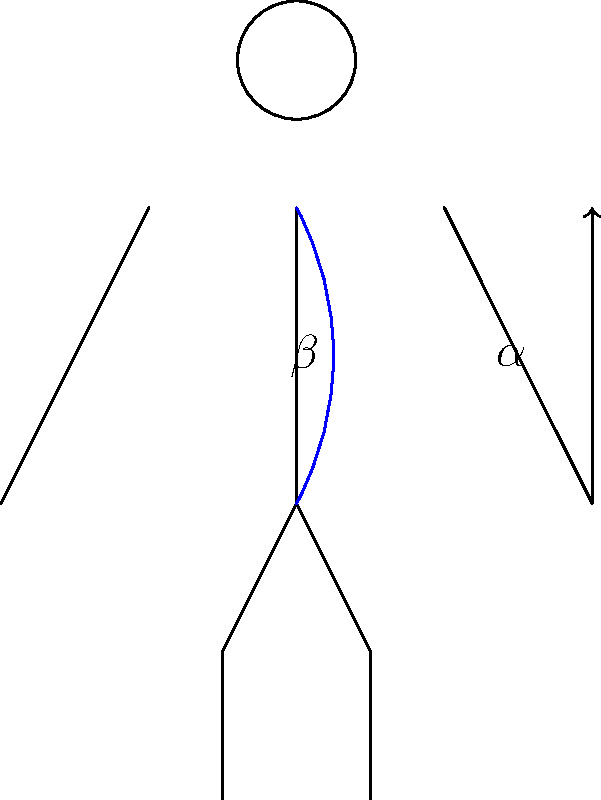In the stick figure illustration of a conductor, angle $\alpha$ represents the angle between the conductor's raised arm and their torso, while angle $\beta$ represents the curvature of their spine. How does increasing angle $\alpha$ likely affect angle $\beta$ and the conductor's back muscles? To understand the relationship between the conductor's arm position and back posture, let's break it down step-by-step:

1. As the conductor raises their arm (increasing angle $\alpha$), the center of gravity of the arm shifts away from the body's midline.

2. This shift creates a moment arm, which is the perpendicular distance between the line of action of the weight force and the axis of rotation (in this case, the spine).

3. The larger moment arm results in an increased torque on the spine, calculated as:
   $$\text{Torque} = \text{Force} \times \text{Moment Arm}$$

4. To counteract this torque and maintain balance, the body naturally adjusts its posture.

5. The primary adjustment is an increase in the curvature of the spine (angle $\beta$), which helps shift the body's center of mass to maintain equilibrium.

6. This increased spinal curvature is achieved through the contraction of the erector spinae muscles along the back.

7. The sustained contraction of these muscles to maintain the curved posture can lead to increased muscle tension and potential fatigue over time.

8. Additionally, the asymmetrical nature of the posture (one arm raised) may cause uneven loading on the spine and surrounding muscles, potentially leading to muscle imbalances.

Therefore, as angle $\alpha$ increases, angle $\beta$ is likely to increase as well, resulting in greater activation and potential strain on the back muscles, particularly the erector spinae.
Answer: Increasing $\alpha$ likely increases $\beta$ and back muscle activation. 